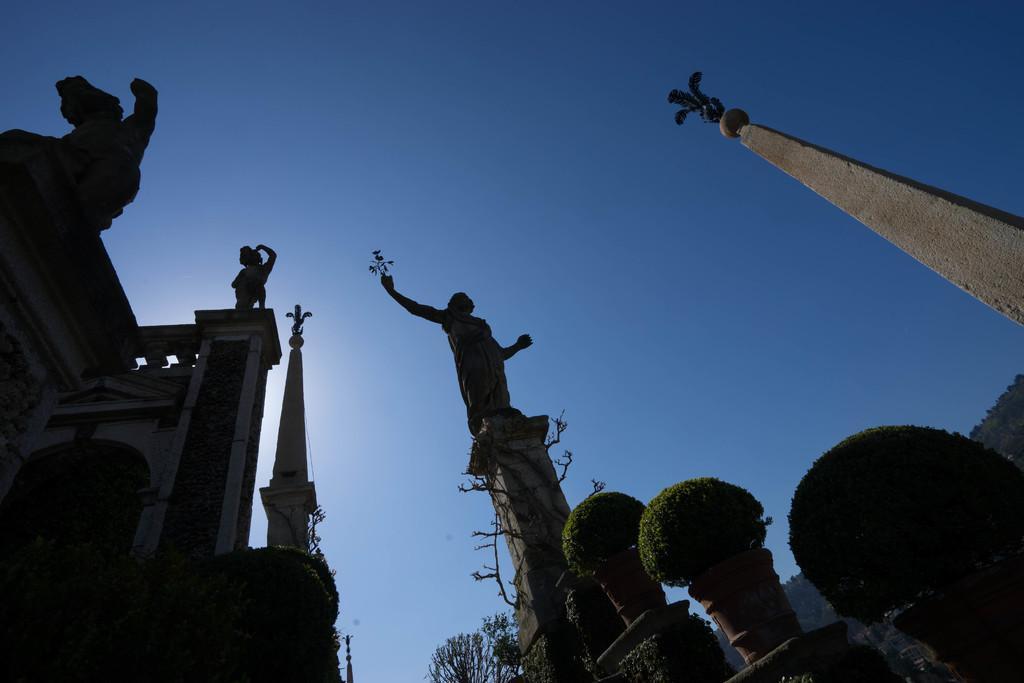Could you give a brief overview of what you see in this image? In this image we can see some statues, pillars, some plants in pots, group of trees and the sky. 